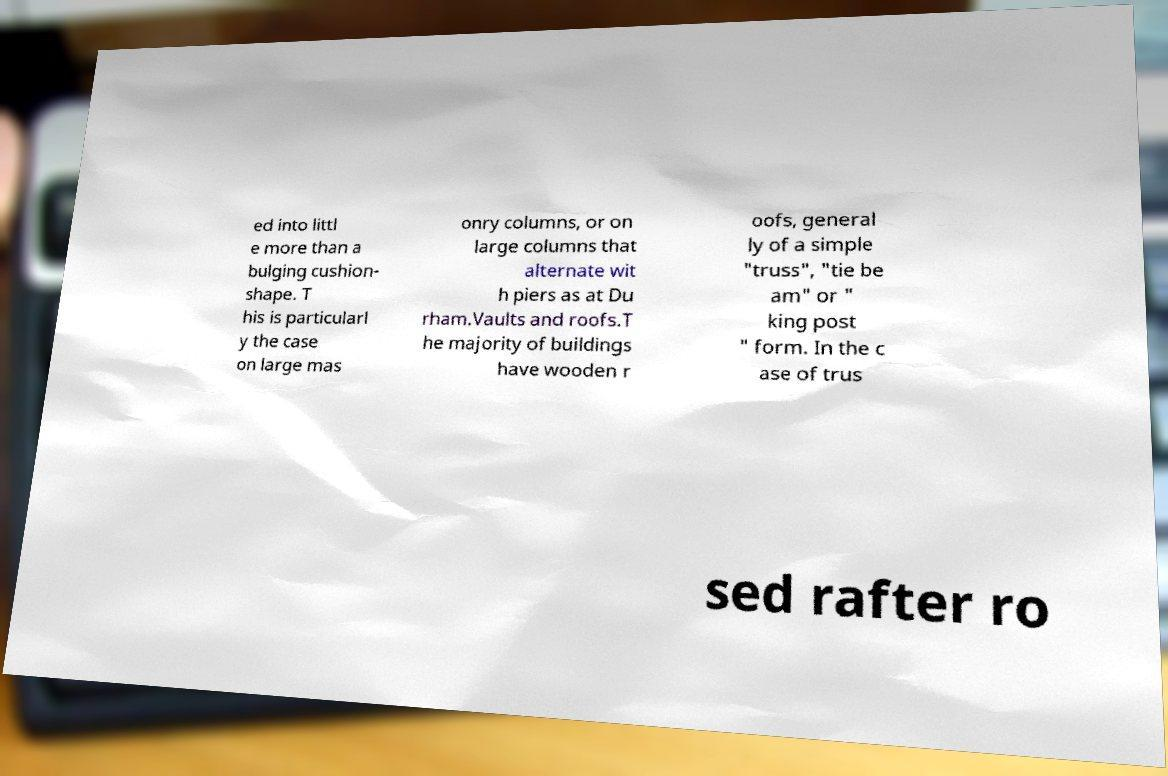Can you read and provide the text displayed in the image?This photo seems to have some interesting text. Can you extract and type it out for me? ed into littl e more than a bulging cushion- shape. T his is particularl y the case on large mas onry columns, or on large columns that alternate wit h piers as at Du rham.Vaults and roofs.T he majority of buildings have wooden r oofs, general ly of a simple "truss", "tie be am" or " king post " form. In the c ase of trus sed rafter ro 